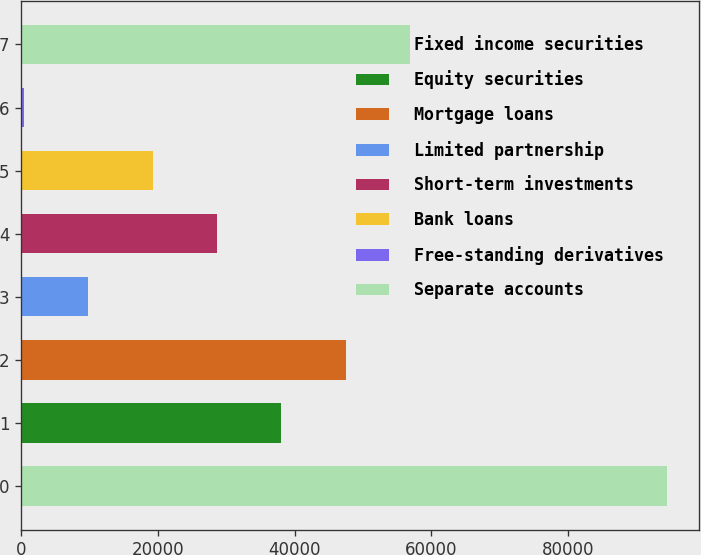Convert chart to OTSL. <chart><loc_0><loc_0><loc_500><loc_500><bar_chart><fcel>Fixed income securities<fcel>Equity securities<fcel>Mortgage loans<fcel>Limited partnership<fcel>Short-term investments<fcel>Bank loans<fcel>Free-standing derivatives<fcel>Separate accounts<nl><fcel>94451<fcel>38065.4<fcel>47463<fcel>9872.6<fcel>28667.8<fcel>19270.2<fcel>475<fcel>56860.6<nl></chart> 